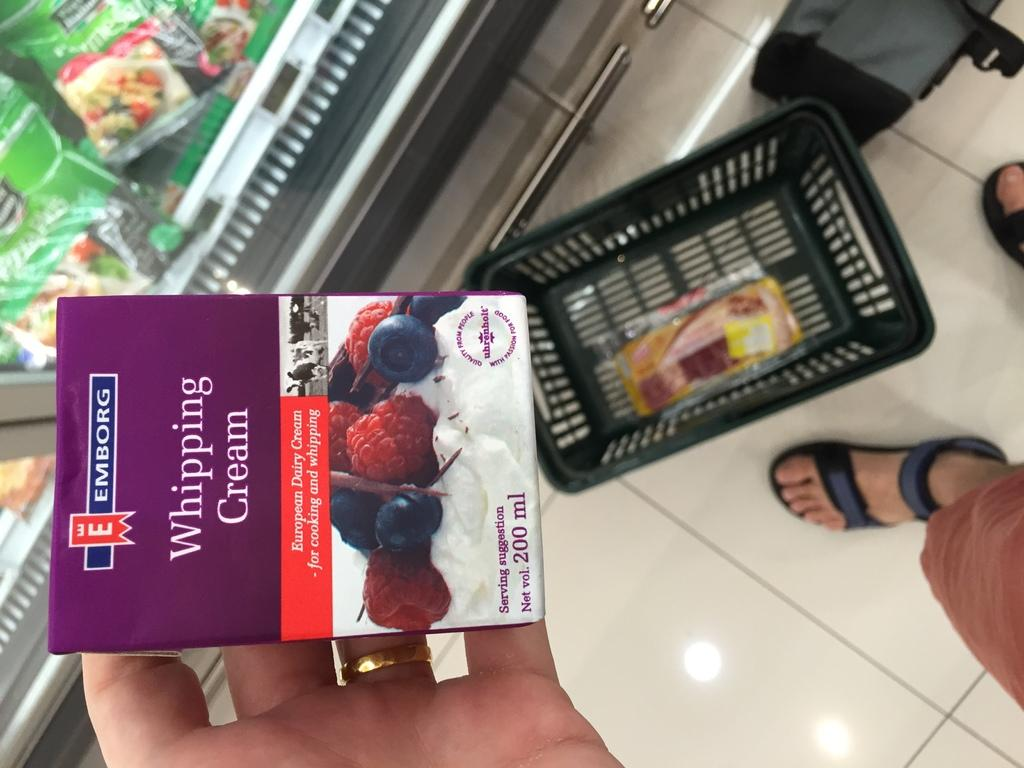<image>
Create a compact narrative representing the image presented. A shopper holds a box of Emborg Whipping Cream in their hand. 